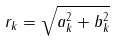Convert formula to latex. <formula><loc_0><loc_0><loc_500><loc_500>r _ { k } = \sqrt { a _ { k } ^ { 2 } + b _ { k } ^ { 2 } }</formula> 